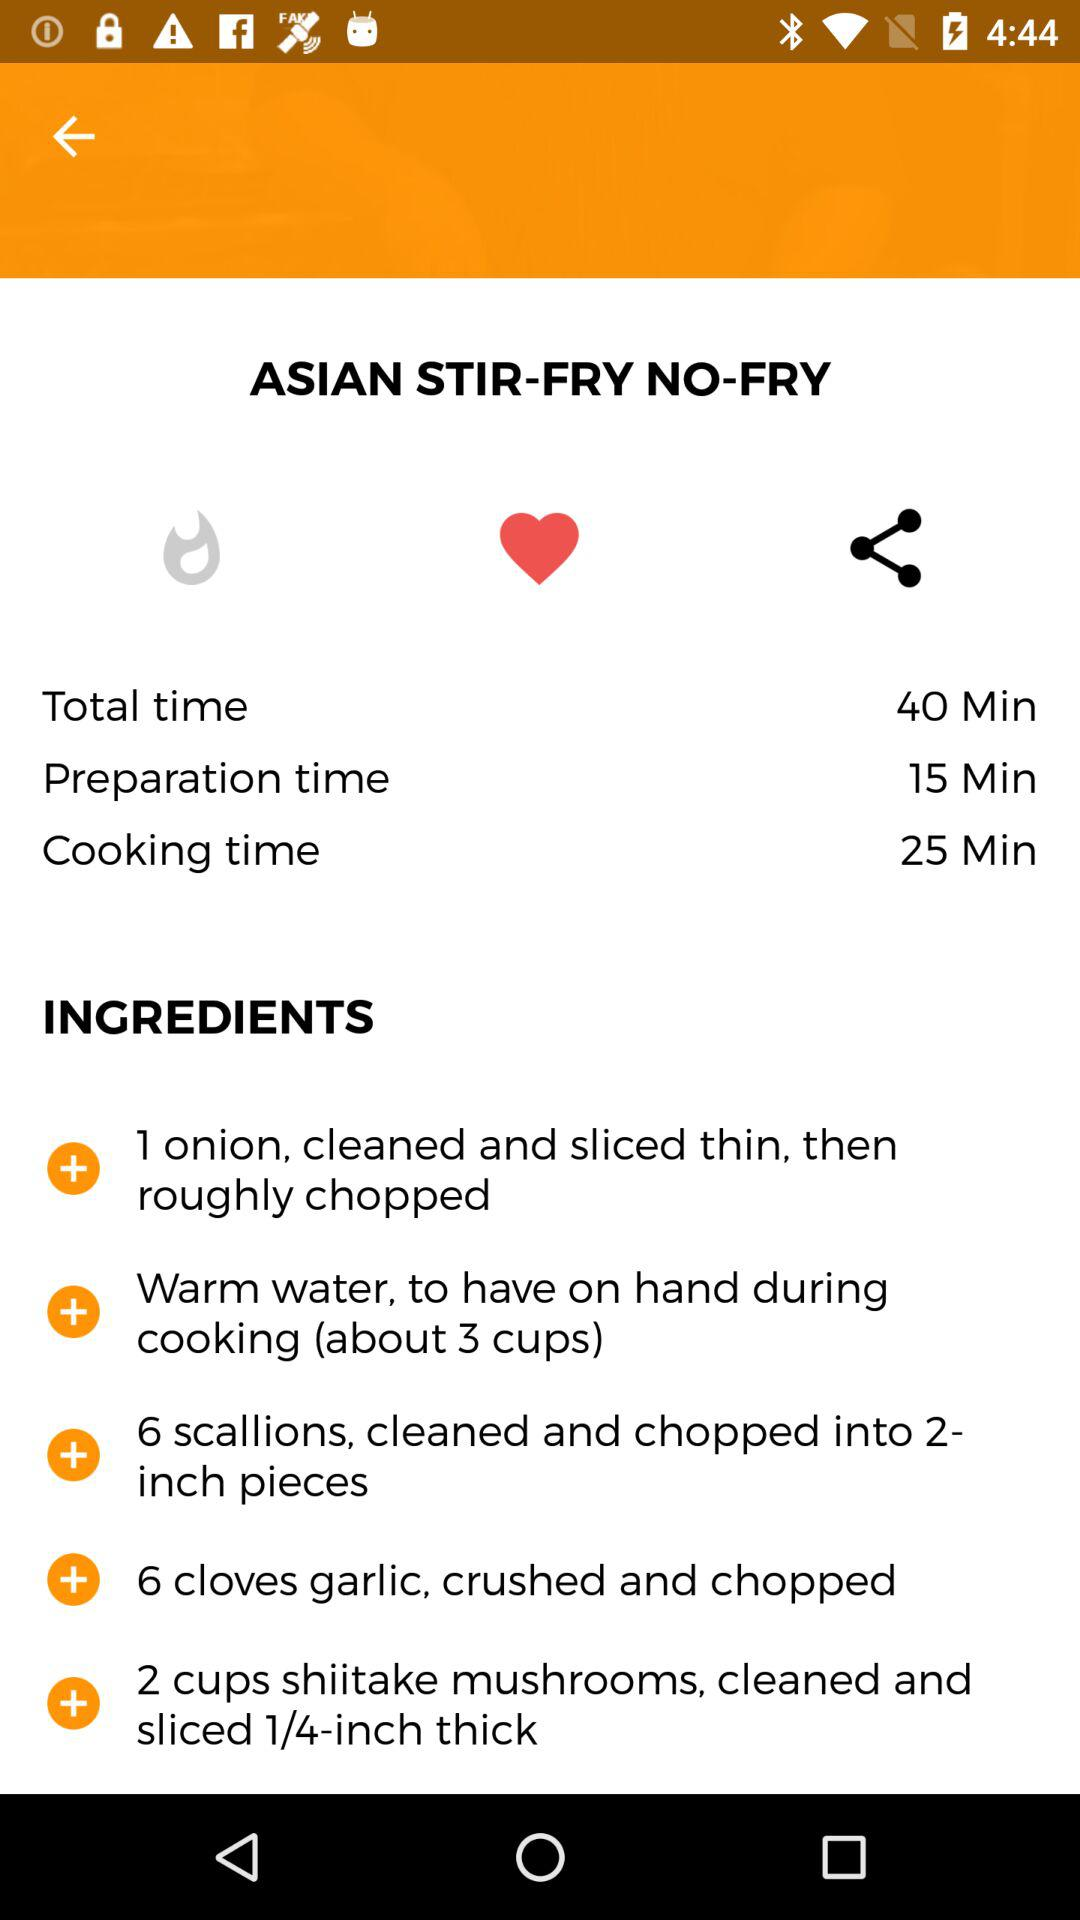What is the total time required to prepare the dish? The total time required to prepare the dish is 40 minutes. 